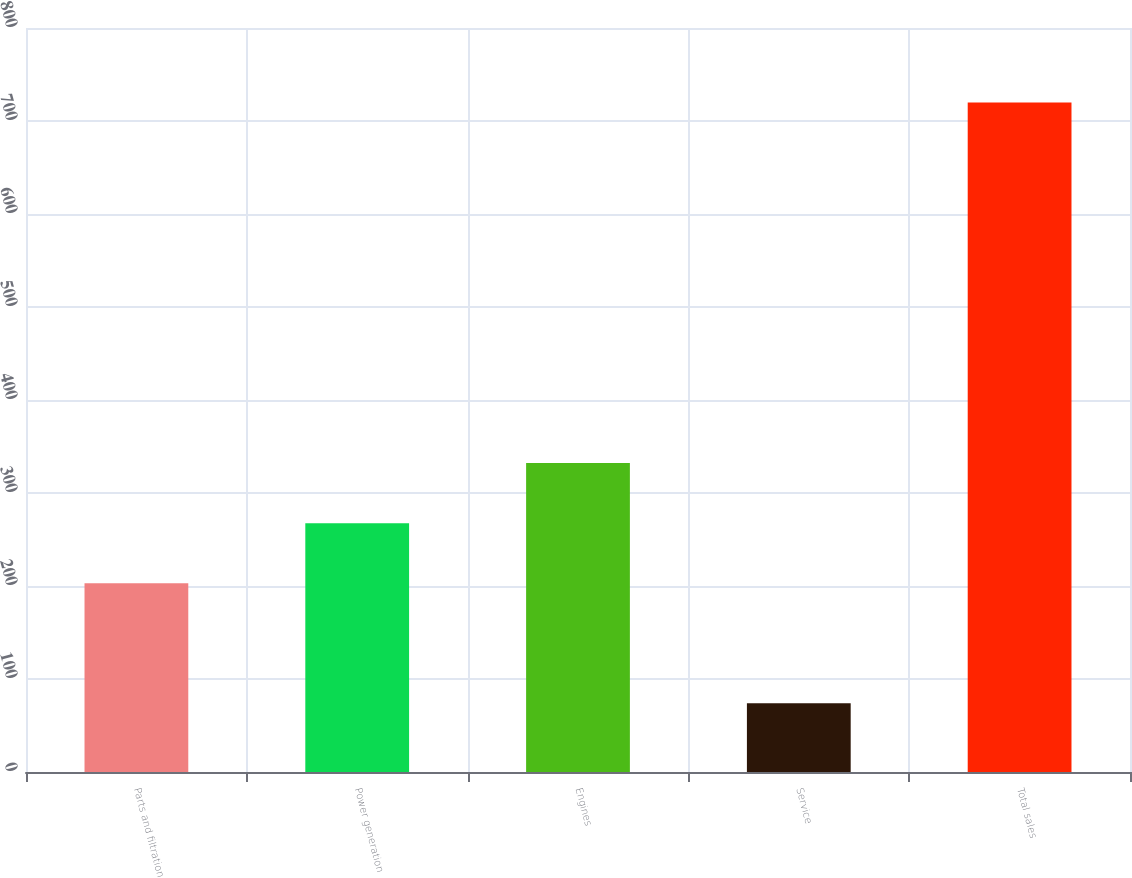<chart> <loc_0><loc_0><loc_500><loc_500><bar_chart><fcel>Parts and filtration<fcel>Power generation<fcel>Engines<fcel>Service<fcel>Total sales<nl><fcel>203<fcel>267.6<fcel>332.2<fcel>74<fcel>720<nl></chart> 